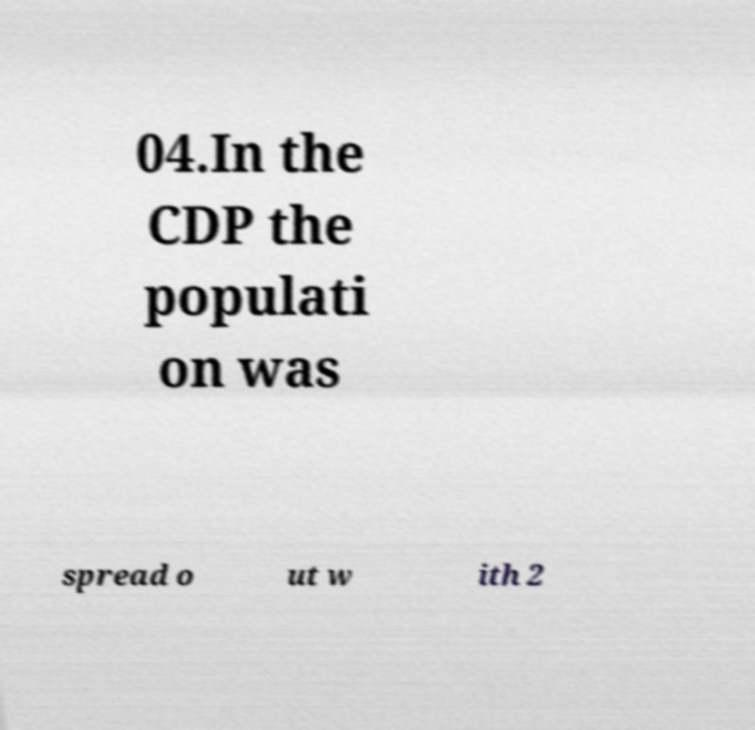Can you accurately transcribe the text from the provided image for me? 04.In the CDP the populati on was spread o ut w ith 2 